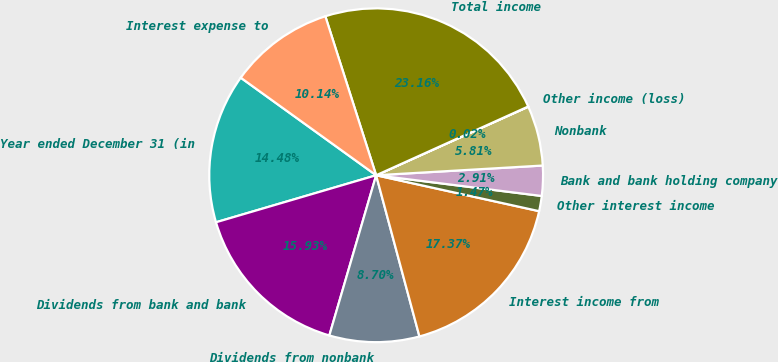<chart> <loc_0><loc_0><loc_500><loc_500><pie_chart><fcel>Year ended December 31 (in<fcel>Dividends from bank and bank<fcel>Dividends from nonbank<fcel>Interest income from<fcel>Other interest income<fcel>Bank and bank holding company<fcel>Nonbank<fcel>Other income (loss)<fcel>Total income<fcel>Interest expense to<nl><fcel>14.48%<fcel>15.93%<fcel>8.7%<fcel>17.37%<fcel>1.47%<fcel>2.91%<fcel>5.81%<fcel>0.02%<fcel>23.16%<fcel>10.14%<nl></chart> 